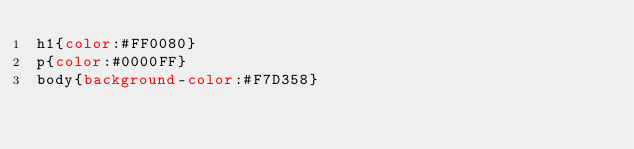<code> <loc_0><loc_0><loc_500><loc_500><_CSS_>h1{color:#FF0080}
p{color:#0000FF}
body{background-color:#F7D358}</code> 